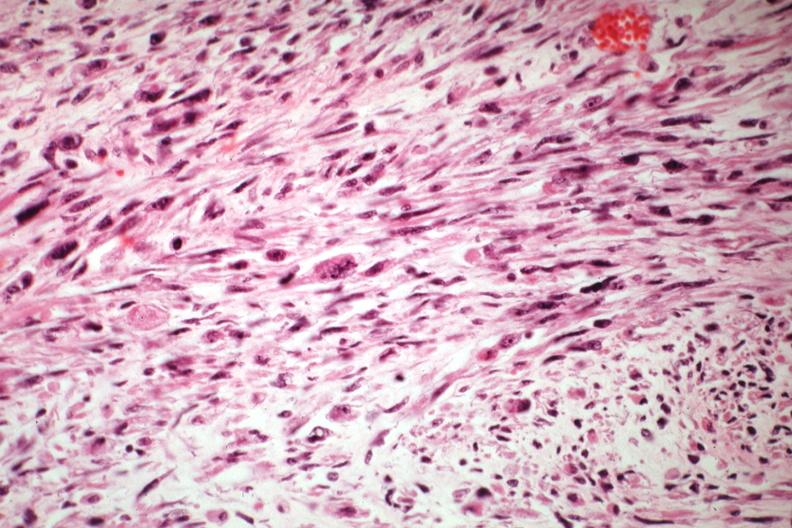s uterus present?
Answer the question using a single word or phrase. Yes 